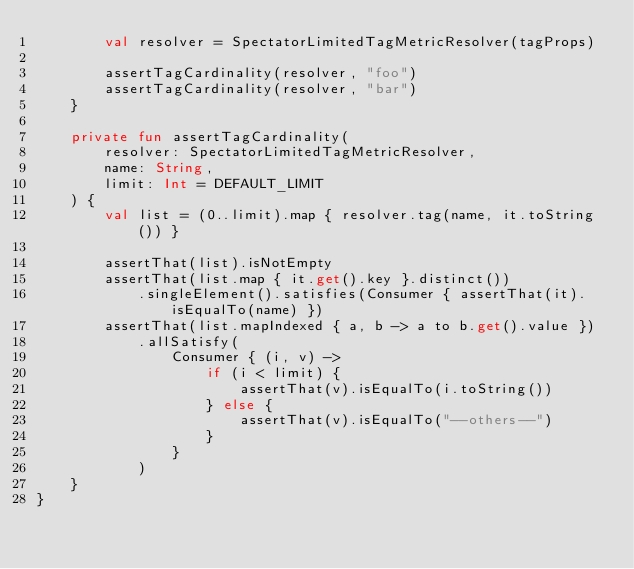<code> <loc_0><loc_0><loc_500><loc_500><_Kotlin_>        val resolver = SpectatorLimitedTagMetricResolver(tagProps)

        assertTagCardinality(resolver, "foo")
        assertTagCardinality(resolver, "bar")
    }

    private fun assertTagCardinality(
        resolver: SpectatorLimitedTagMetricResolver,
        name: String,
        limit: Int = DEFAULT_LIMIT
    ) {
        val list = (0..limit).map { resolver.tag(name, it.toString()) }

        assertThat(list).isNotEmpty
        assertThat(list.map { it.get().key }.distinct())
            .singleElement().satisfies(Consumer { assertThat(it).isEqualTo(name) })
        assertThat(list.mapIndexed { a, b -> a to b.get().value })
            .allSatisfy(
                Consumer { (i, v) ->
                    if (i < limit) {
                        assertThat(v).isEqualTo(i.toString())
                    } else {
                        assertThat(v).isEqualTo("--others--")
                    }
                }
            )
    }
}
</code> 